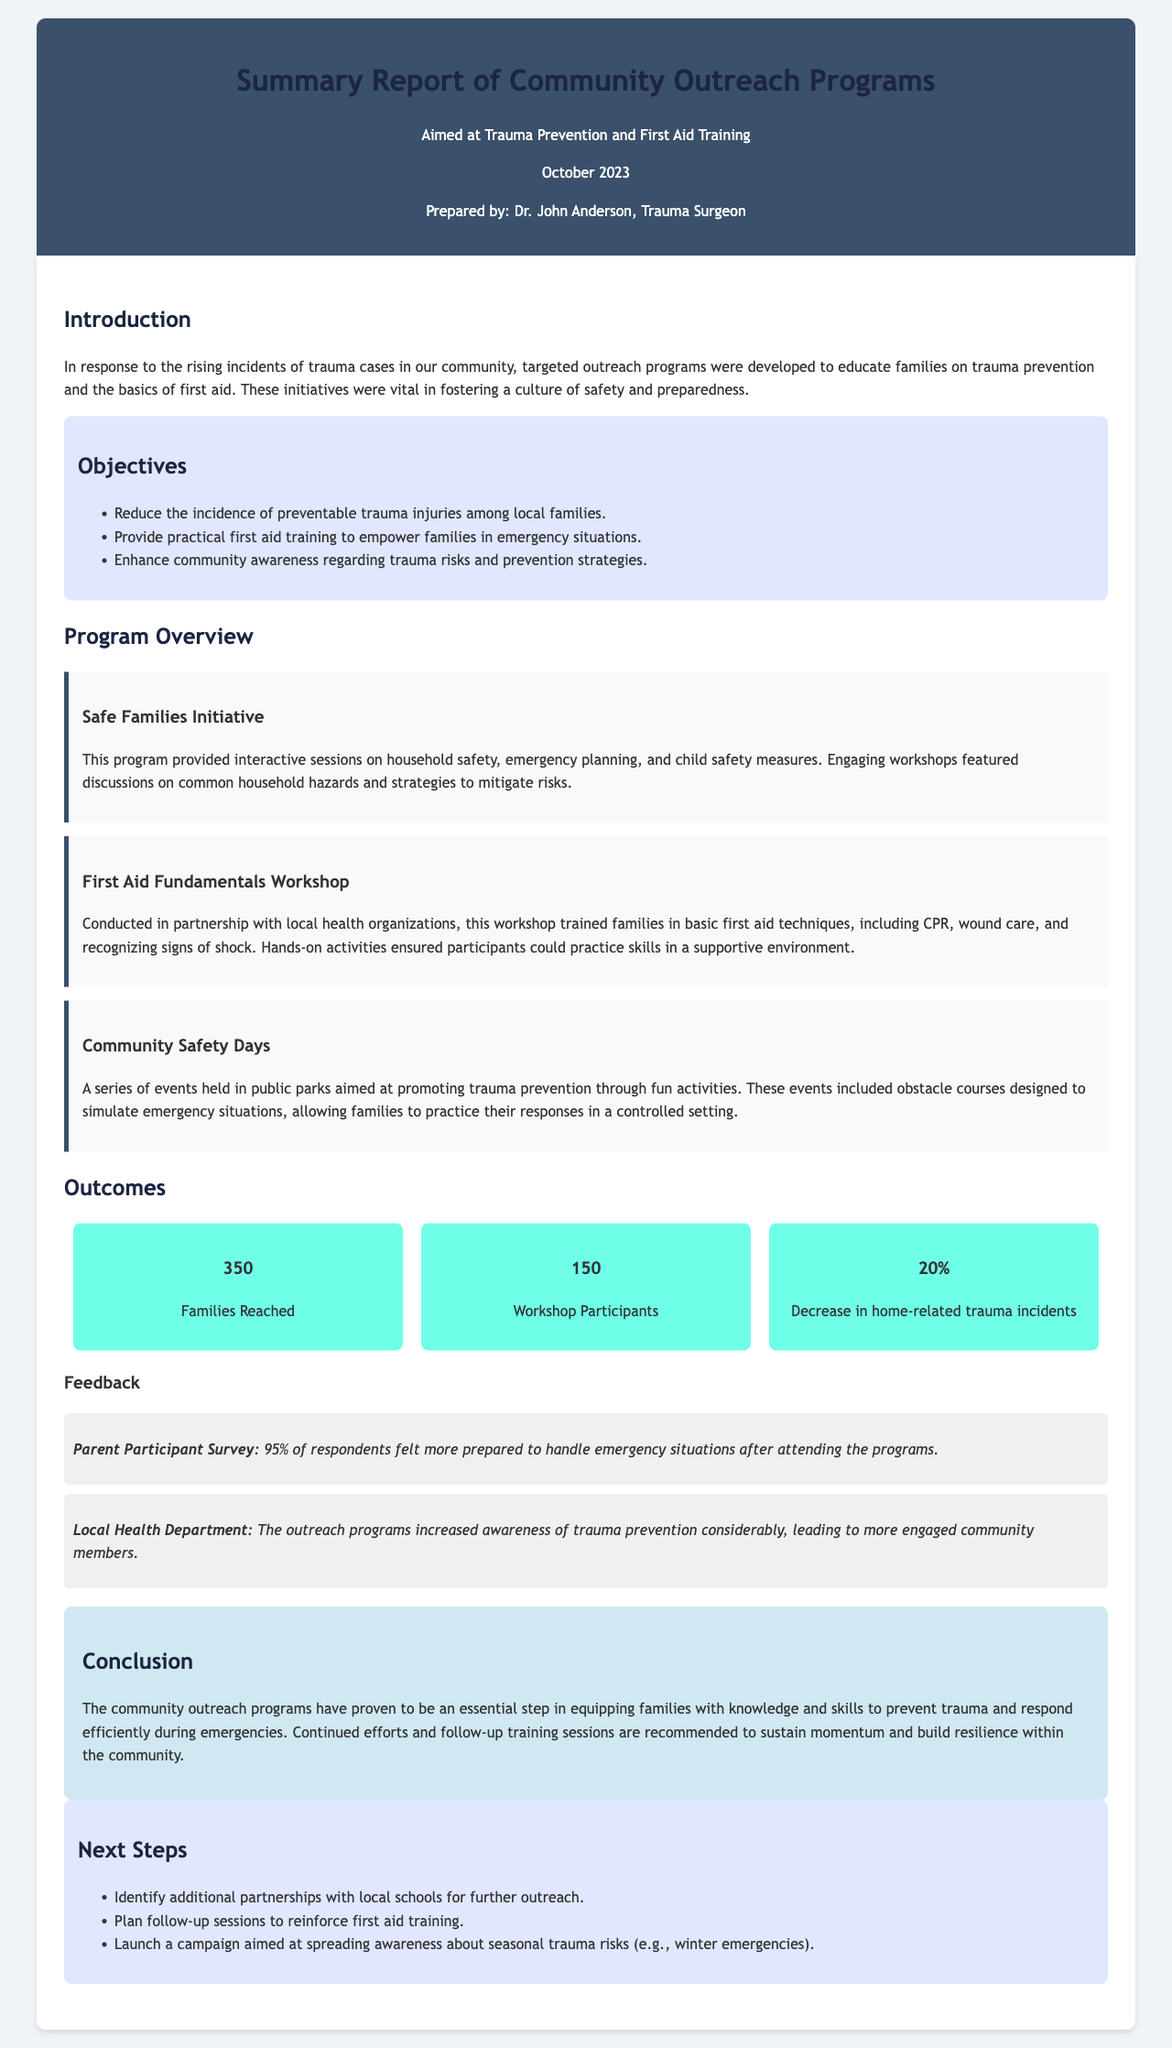what is the title of the report? The title of the report is stated prominently in the header, summarizing its purpose and focus area.
Answer: Summary Report of Community Outreach Programs who prepared the report? The report mentions the individual's name who has prepared it at the end of the header section.
Answer: Dr. John Anderson how many families were reached by the programs? The number of families reached is highlighted in the outcomes section as a key statistic.
Answer: 350 what percentage of respondents felt more prepared after attending the programs? The percentage of respondents feeling more prepared is clearly indicated in the feedback section from the parent participant survey.
Answer: 95% which program included discussions on common household hazards? The name of the program that focused on household safety and emergency planning is specified in its description.
Answer: Safe Families Initiative what is the next step planned regarding outreach efforts? The next steps section outlines future actions to enhance community outreach, detailing various intended initiatives.
Answer: Identify additional partnerships what was the decrease in home-related trauma incidents? A specific statistic indicating the impact of the outreach programs on trauma incidents is provided in the outcomes section.
Answer: 20% what type of event was conducted to promote trauma prevention? The document describes specific types of events aimed at increasing awareness of trauma prevention strategies.
Answer: Community Safety Days what was the objective related to trauma injury incidence? One of the objectives states a specific goal regarding the reduction of trauma incidents.
Answer: Reduce the incidence of preventable trauma injuries 